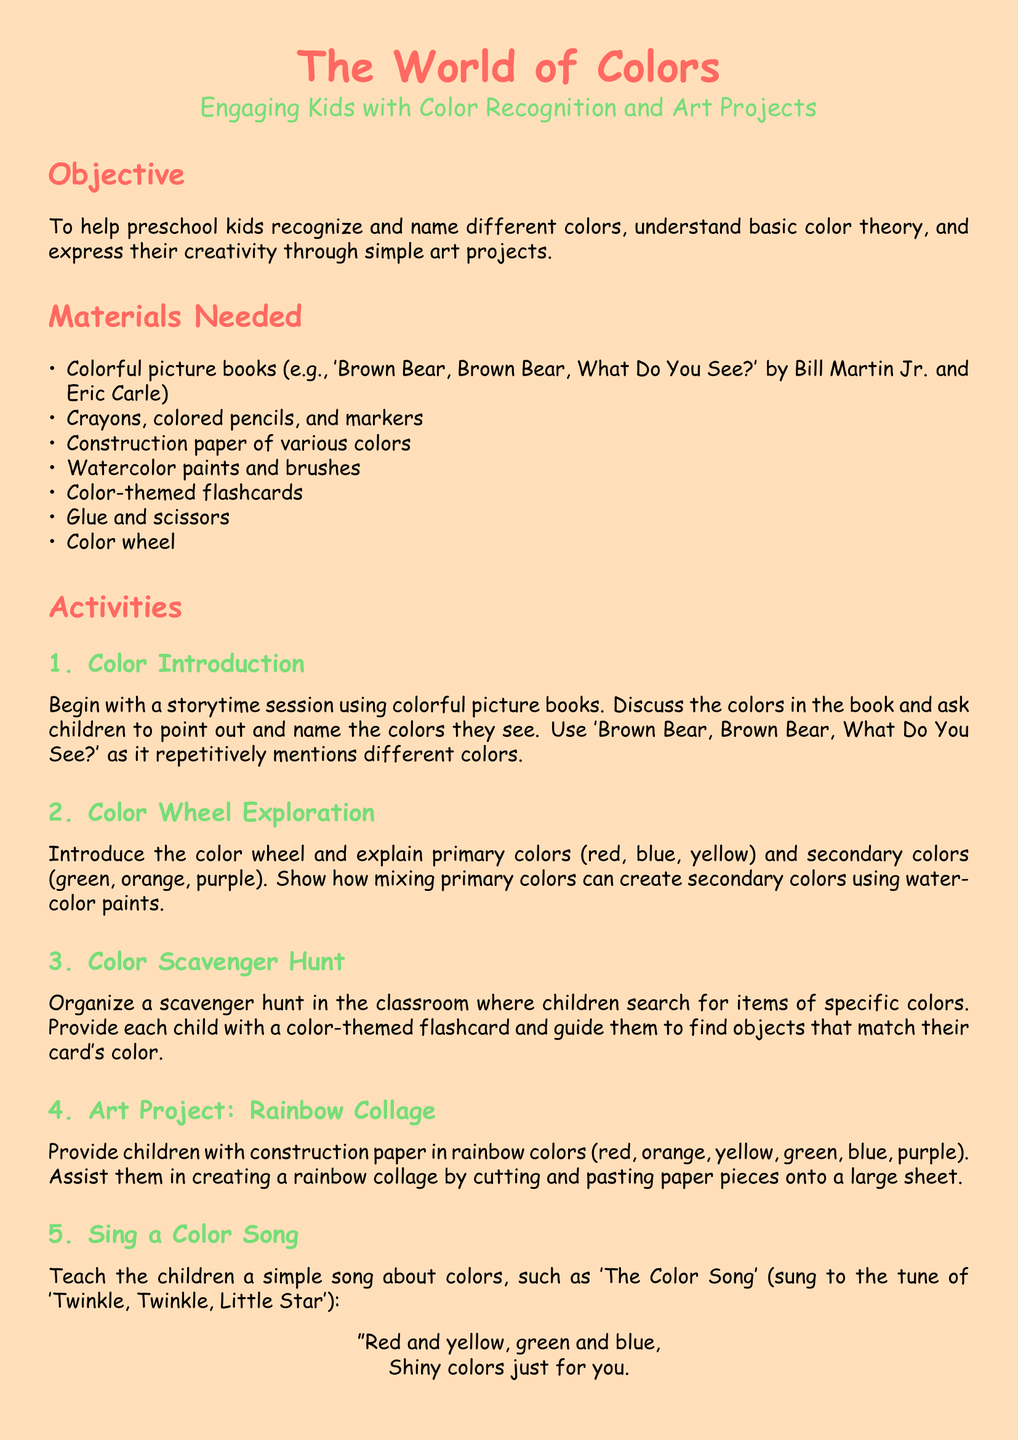What is the main objective of the lesson plan? The objective outlines the primary aim of the lesson plan, which is to help preschool kids recognize and name different colors, understand basic color theory, and express their creativity through simple art projects.
Answer: To help preschool kids recognize and name different colors, understand basic color theory, and express their creativity through simple art projects How many primary colors are introduced? The lesson plan explicitly states the introduction of primary colors for understanding color theory, which are three in total.
Answer: 3 Which picture book is recommended for storytime? The document specifies a particular book that should be used to engage children during the color introduction activity.
Answer: 'Brown Bear, Brown Bear, What Do You See?' What materials are needed for the art project? The materials list includes specific supplies, and the art project, a rainbow collage, requires construction paper in rainbow colors.
Answer: Construction paper in rainbow colors What is one method of evaluation mentioned? The evaluation section describes how to assess children’s color recognition and comprehension through direct observation and review of completed tasks.
Answer: Observe children's ability to name and identify different colors during the activities How many colors should children be able to identify to meet the evaluation criteria? The document states a specific expectation regarding children's identification skills concerning color recognition.
Answer: At least five different colors What activity involves using a color wheel? The lesson plan describes a particular activity designed to introduce and explain the relationships between primary and secondary colors using a visual tool.
Answer: Color Wheel Exploration Which song is suggested to teach about colors? The plan includes a specific song to teach children about colors, stating its melody reference for context.
Answer: 'The Color Song' How will children's understanding of color mixing be assessed? The criteria section outlines the expectations for children in demonstrating their grasp of color theory through both verbal and artistic means.
Answer: Children show an understanding of how primary colors mix to create secondary colors 